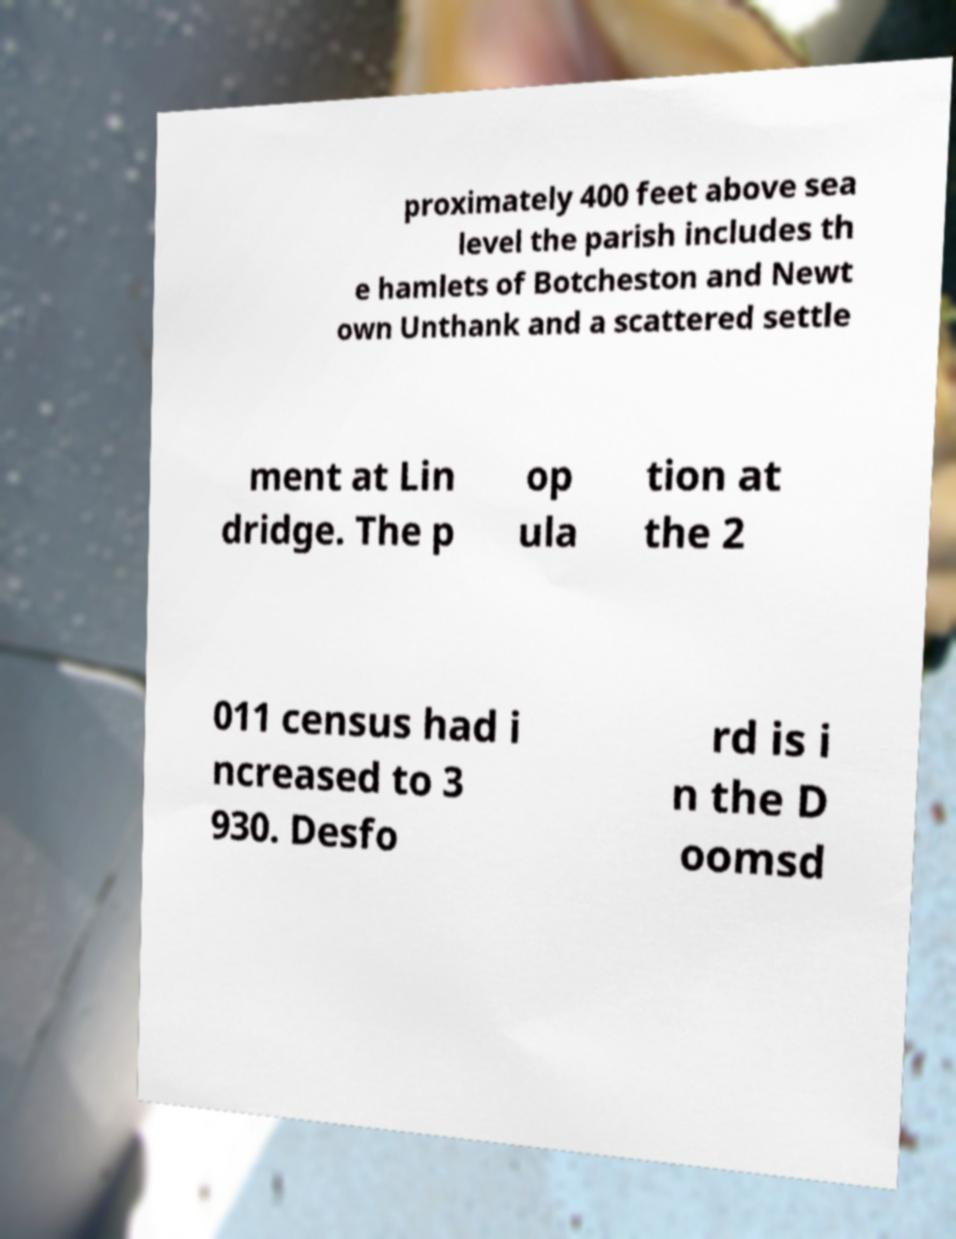Could you extract and type out the text from this image? proximately 400 feet above sea level the parish includes th e hamlets of Botcheston and Newt own Unthank and a scattered settle ment at Lin dridge. The p op ula tion at the 2 011 census had i ncreased to 3 930. Desfo rd is i n the D oomsd 